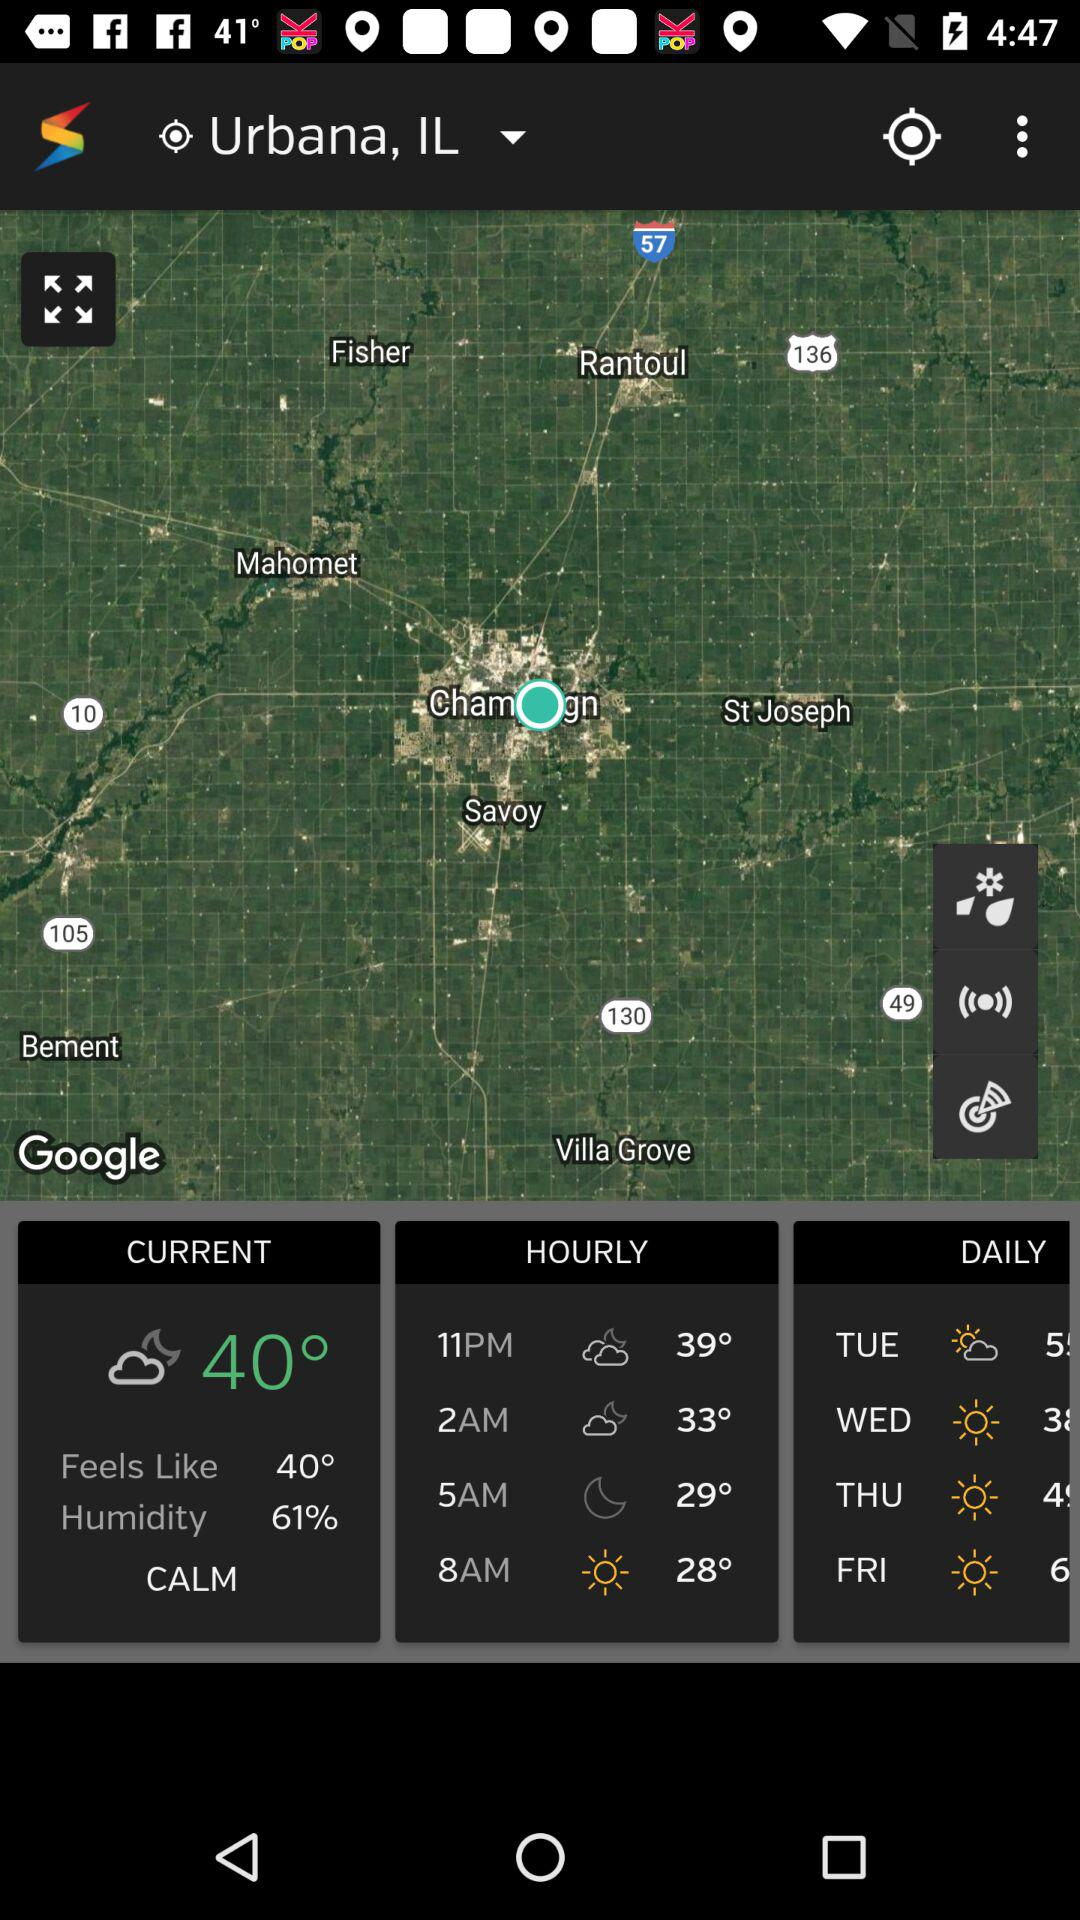What is the current temperature? The current temperature is 40 degrees. 